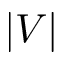Convert formula to latex. <formula><loc_0><loc_0><loc_500><loc_500>| V |</formula> 